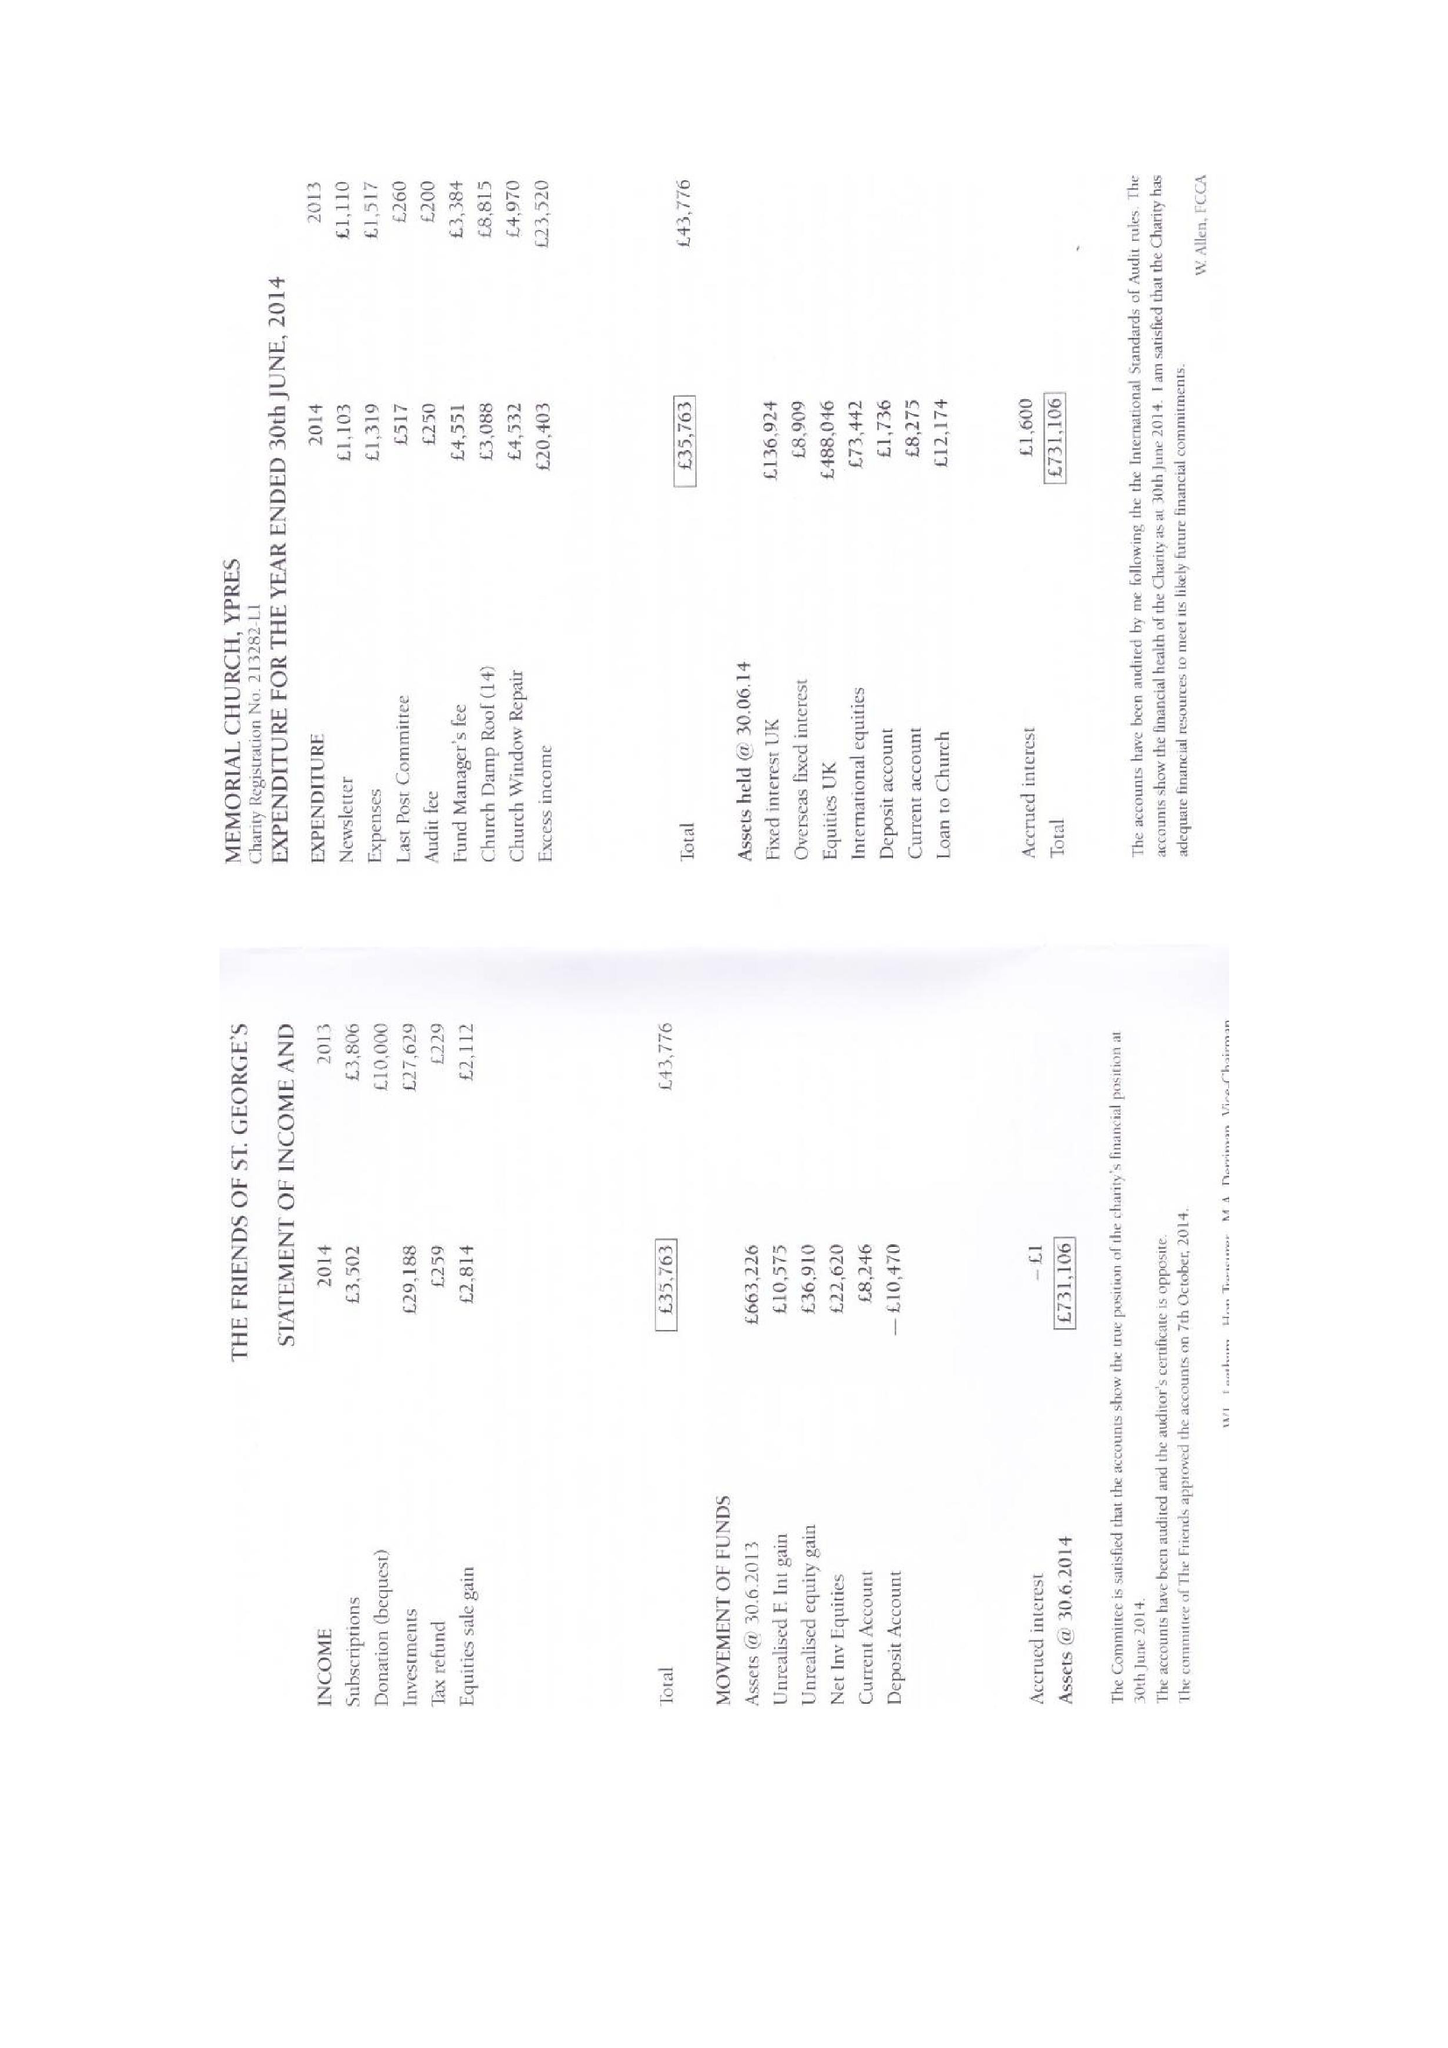What is the value for the spending_annually_in_british_pounds?
Answer the question using a single word or phrase. 15360.00 